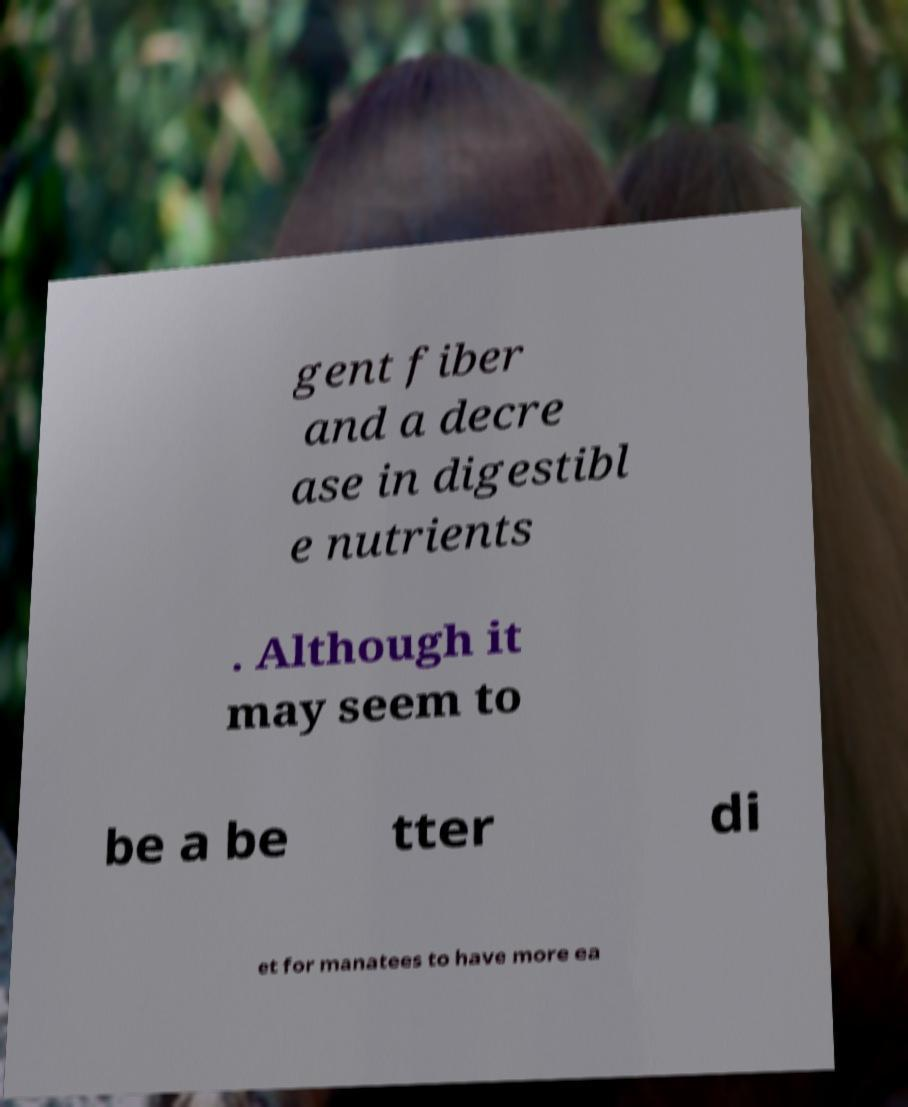Can you read and provide the text displayed in the image?This photo seems to have some interesting text. Can you extract and type it out for me? gent fiber and a decre ase in digestibl e nutrients . Although it may seem to be a be tter di et for manatees to have more ea 